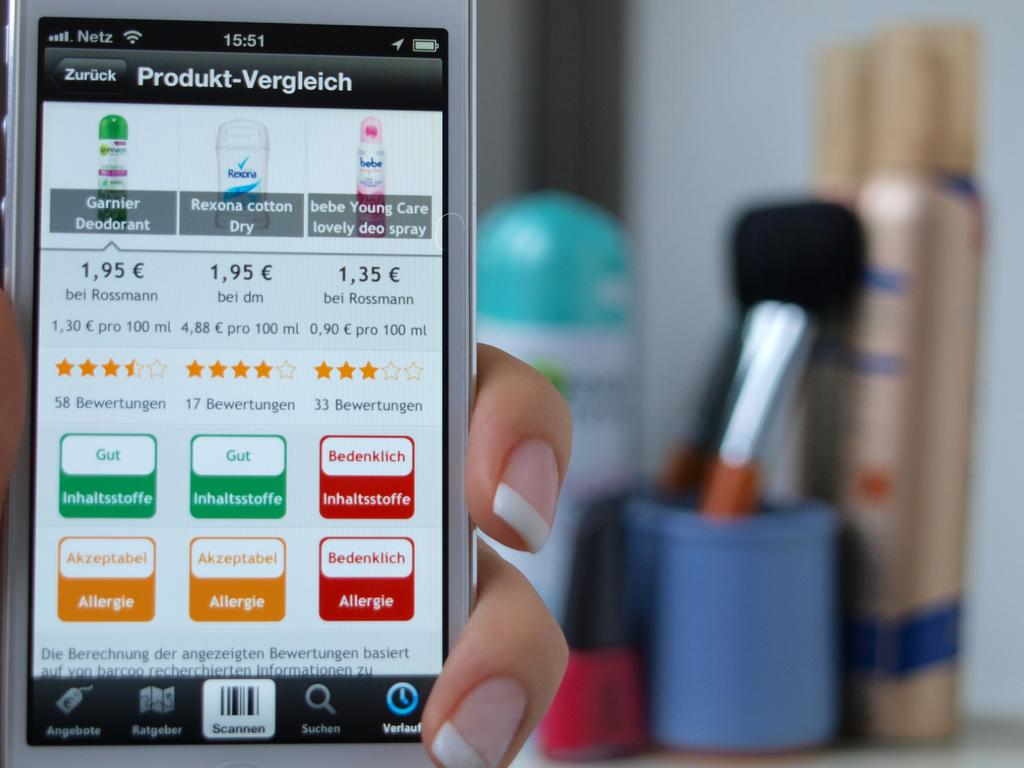<image>
Give a short and clear explanation of the subsequent image. At the top of the device, the time states 15:51. 